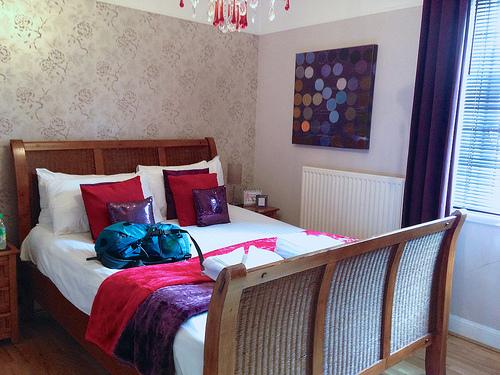Describe the bedding textiles according to their colors. The sheets are white, the blankets are red and purple, and the pillows include white, red, and purple. Provide a brief overview of the dominant objects in the image. A wooden bed with red and purple pillows, white sheets, and red and purple blankets is against a wall, near a window with white blinds, and a heater. Mention the main elements present in the image involving color. There is a bed with red and purple pillows, a red and purple blanket, white sheets, purple curtains on a window, and a wall with a painting. In a few words, describe the general appearance of the room. A cozy room with a colorful bed, a heater, a window, and a chandelier hanging from the ceiling. Describe the arrangement of pillows on the bed. Several pillows are stacked on the bed, including two white pillows, a small red throw pillow, a small purple throw pillow, and a dark red throw pillow. What are the primary colors seen in the blankets and pillows? Red, purple, and white are the primary colors seen in the blankets and pillows on the bed. Identify the elements on the wall in the image. A painting, a piece of purple art, and wallpaper adorn the wall, accompanied by a chandelier hanging from the ceiling. What are the window decorations in the room? The window has white blinds, purple curtains, and a curtain pulled back to let in daylight. List the main furniture items in the room. A wooden bed, a heater, a window with blinds, a nightstand, a chandelier, and a painting on the wall. Mention the different types of pillows on the bed. The bed has white pillows, red throw pillows, purple throw pillows, and dark red throw pillows. 